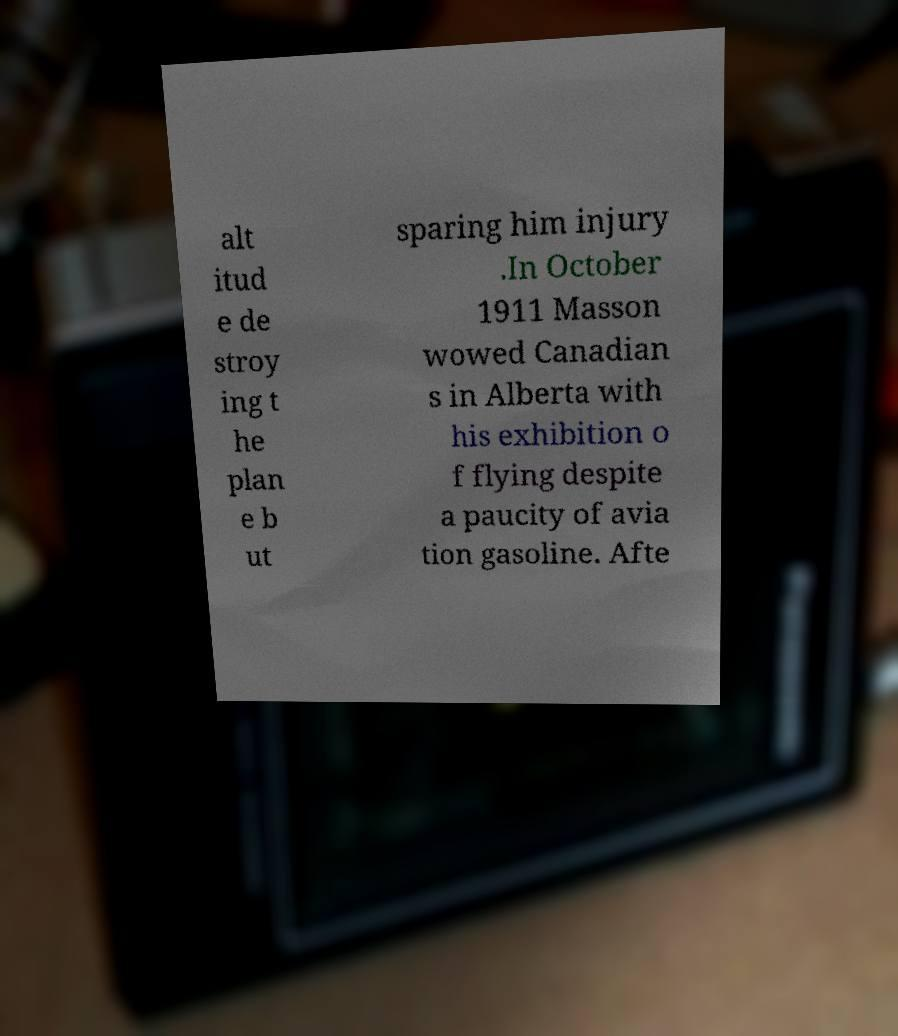Can you read and provide the text displayed in the image?This photo seems to have some interesting text. Can you extract and type it out for me? alt itud e de stroy ing t he plan e b ut sparing him injury .In October 1911 Masson wowed Canadian s in Alberta with his exhibition o f flying despite a paucity of avia tion gasoline. Afte 